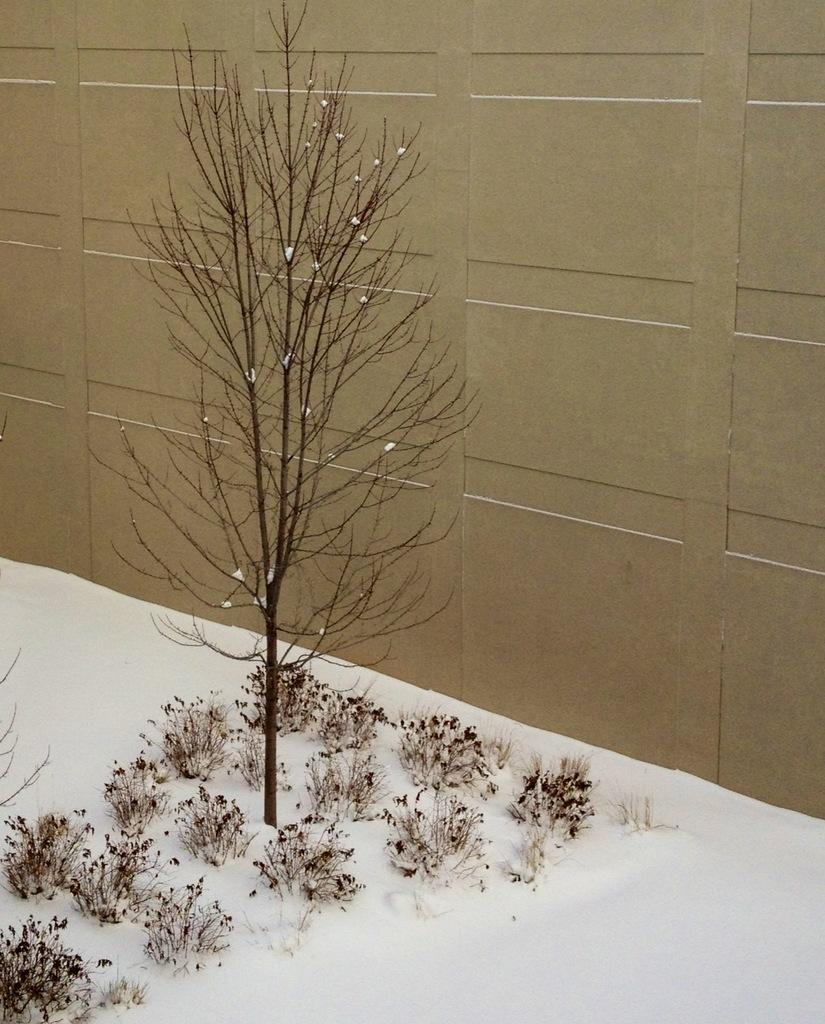What is the main structure in the image? There is a big wall in the image. What type of natural element can be seen in the image? There is a tree in the image. What is present on the surface of the image? There are plants and snow on the surface in the image. How many marks can be seen on the tree in the image? There are no marks visible on the tree in the image. What type of cattle is present in the image? There is no cattle present in the image. 